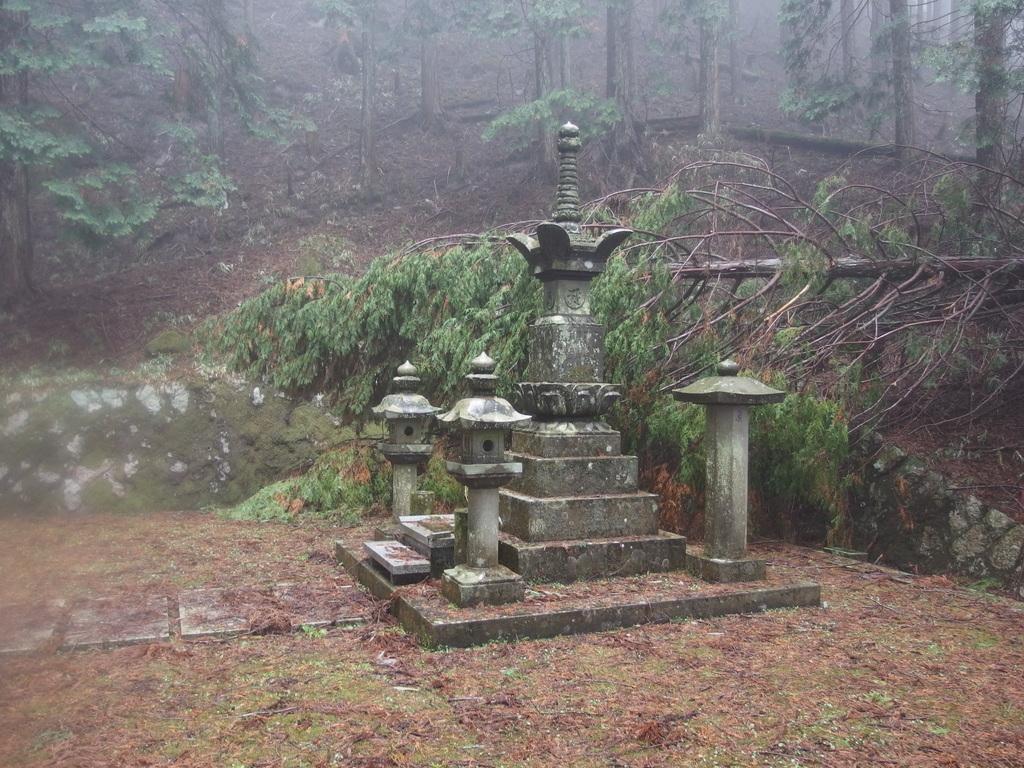Can you describe this image briefly? In this picture I can see trees and it looks like a memorial and I can see a fallen tree. 